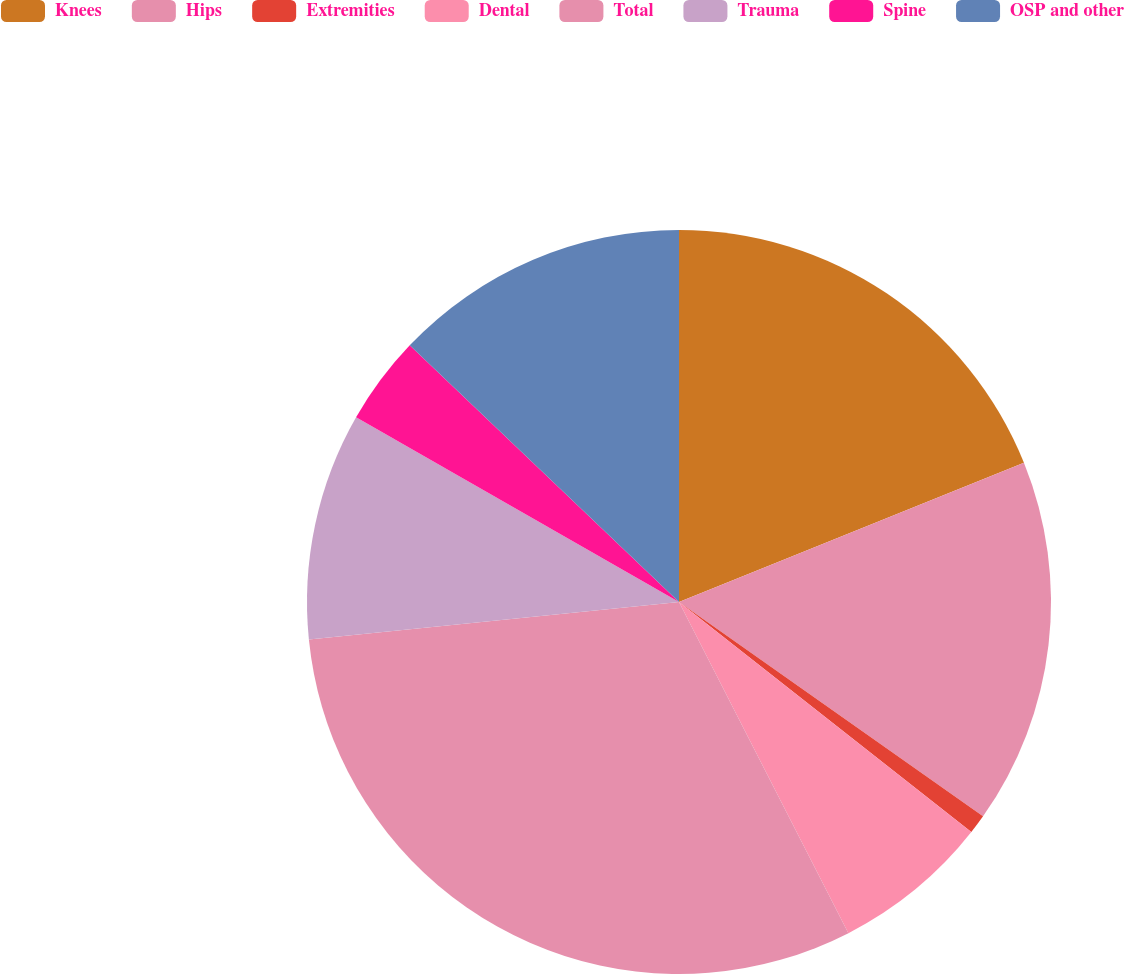<chart> <loc_0><loc_0><loc_500><loc_500><pie_chart><fcel>Knees<fcel>Hips<fcel>Extremities<fcel>Dental<fcel>Total<fcel>Trauma<fcel>Spine<fcel>OSP and other<nl><fcel>18.89%<fcel>15.88%<fcel>0.84%<fcel>6.86%<fcel>30.92%<fcel>9.87%<fcel>3.85%<fcel>12.88%<nl></chart> 